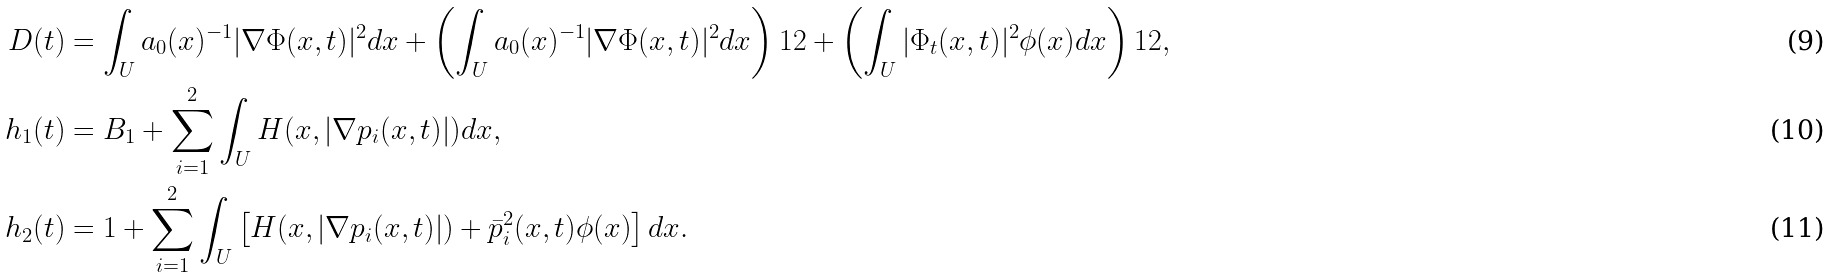<formula> <loc_0><loc_0><loc_500><loc_500>D ( t ) & = \int _ { U } a _ { 0 } ( x ) ^ { - 1 } | \nabla \Phi ( x , t ) | ^ { 2 } d x + \left ( \int _ { U } a _ { 0 } ( x ) ^ { - 1 } | \nabla \Phi ( x , t ) | ^ { 2 } d x \right ) ^ { } { 1 } 2 + \left ( \int _ { U } | \Phi _ { t } ( x , t ) | ^ { 2 } \phi ( x ) d x \right ) ^ { } { 1 } 2 , \\ h _ { 1 } ( t ) & = B _ { 1 } + \sum _ { i = 1 } ^ { 2 } \int _ { U } H ( x , | \nabla p _ { i } ( x , t ) | ) d x , \\ h _ { 2 } ( t ) & = 1 + \sum _ { i = 1 } ^ { 2 } \int _ { U } \left [ H ( x , | \nabla p _ { i } ( x , t ) | ) + \bar { p } _ { i } ^ { 2 } ( x , t ) \phi ( x ) \right ] d x .</formula> 